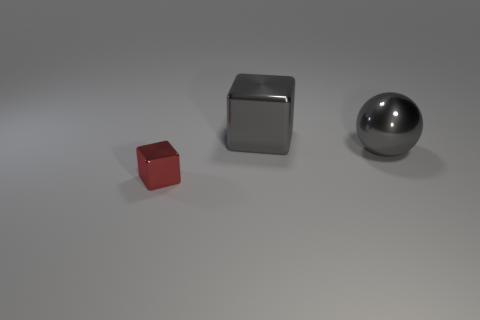What materials are the objects in the image made of? The objects in the image appear to be made of different materials. The small red object on the left looks like it is made of a matte material, possibly plastic. The middle block seems to be composed of metal, given its reflective surface and edges. Lastly, the sphere on the right exhibits a metallic and shiny surface, which reflects the surroundings, suggesting it is also made of metal. 